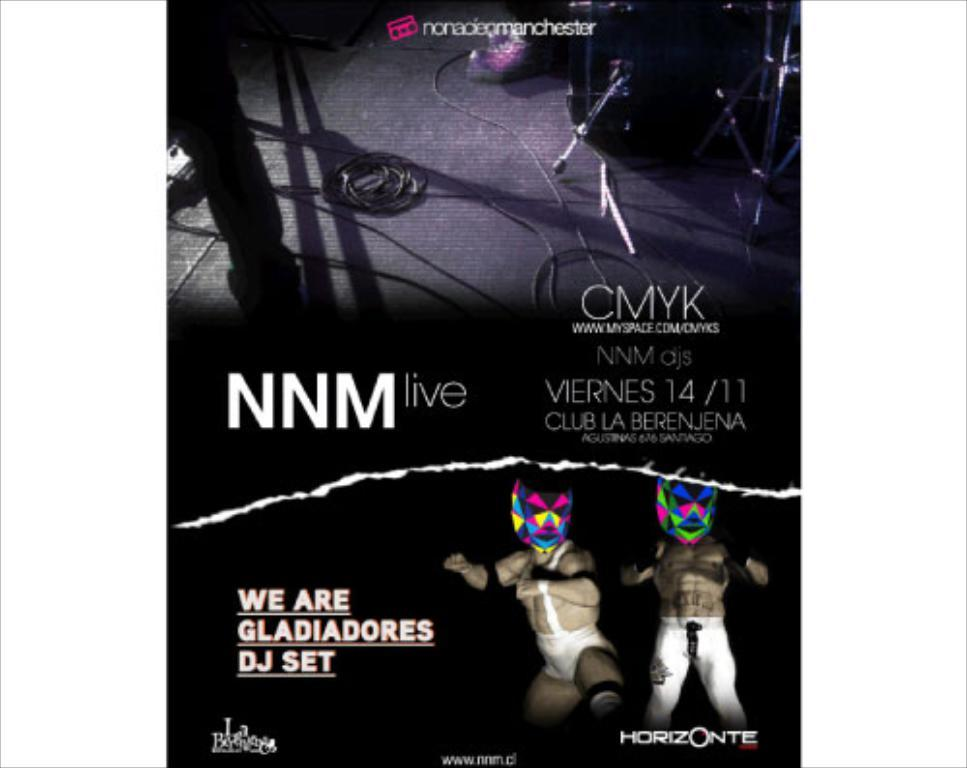Provide a one-sentence caption for the provided image. A poster for NNM live with two character posing over a Horizonte sign. 